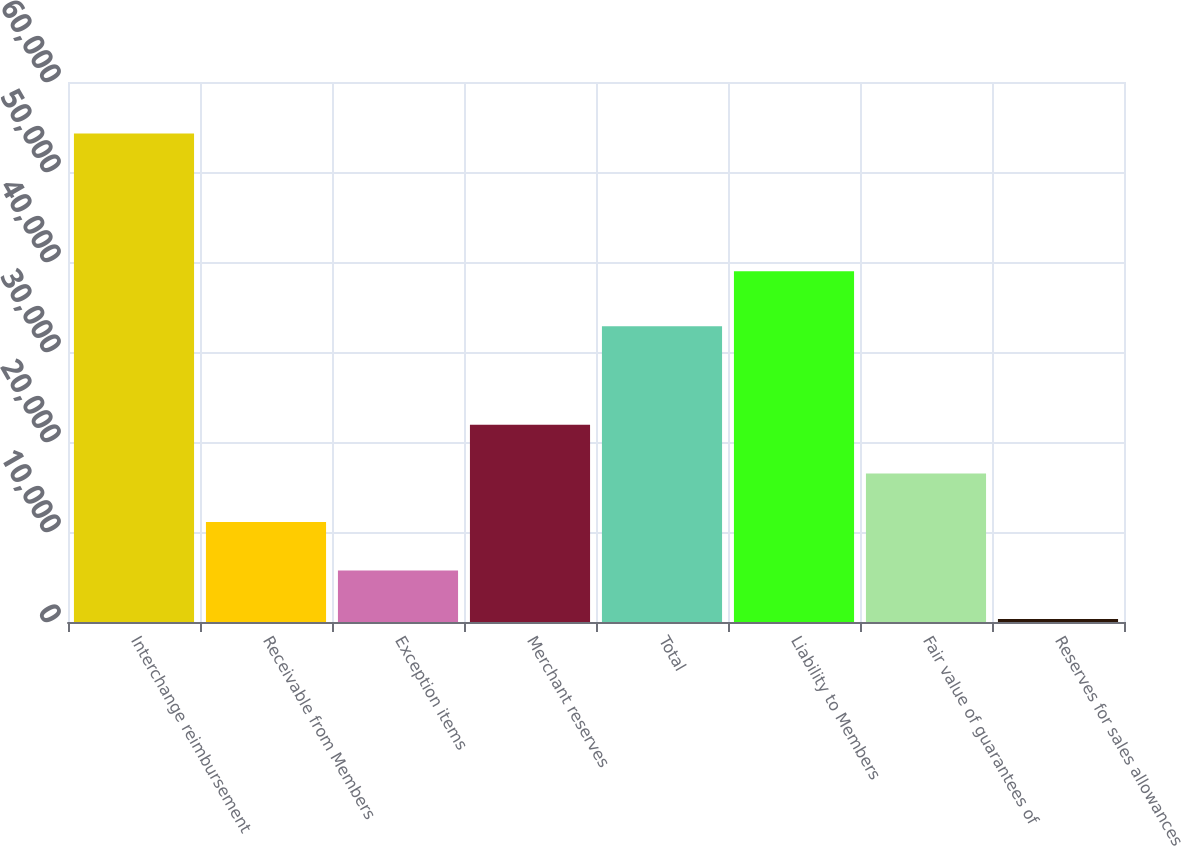Convert chart to OTSL. <chart><loc_0><loc_0><loc_500><loc_500><bar_chart><fcel>Interchange reimbursement<fcel>Receivable from Members<fcel>Exception items<fcel>Merchant reserves<fcel>Total<fcel>Liability to Members<fcel>Fair value of guarantees of<fcel>Reserves for sales allowances<nl><fcel>54279<fcel>11118.2<fcel>5723.1<fcel>21908.4<fcel>32853<fcel>38986<fcel>16513.3<fcel>328<nl></chart> 